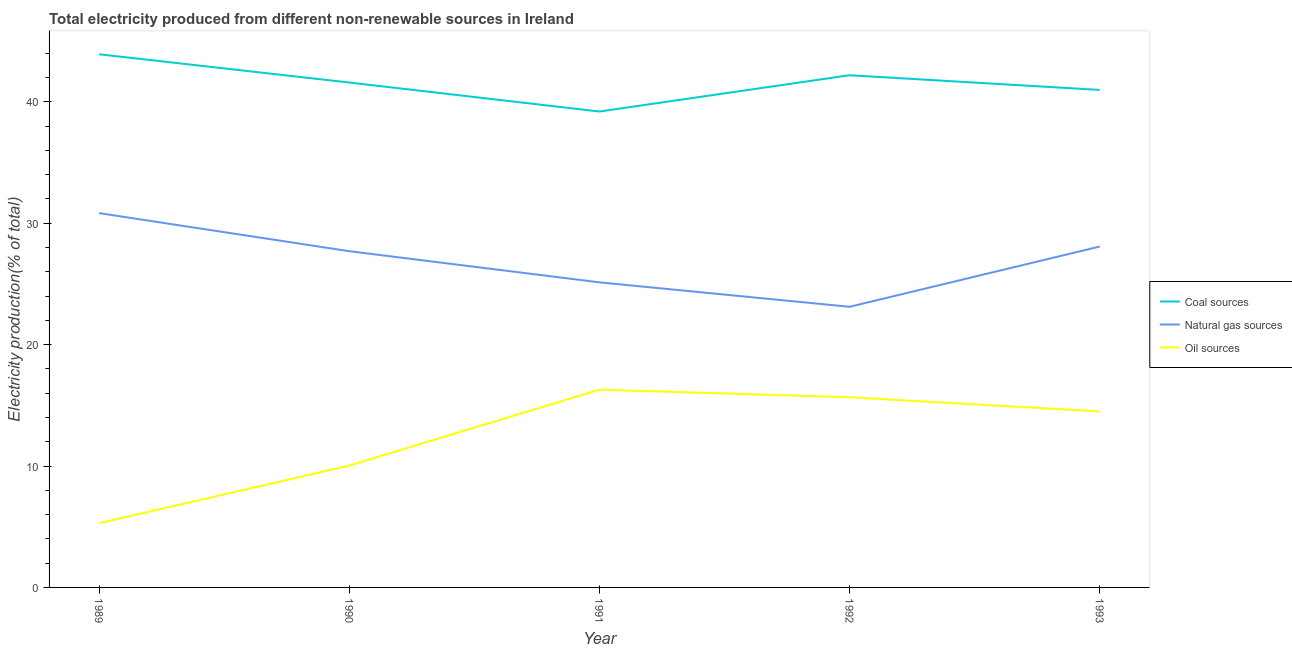How many different coloured lines are there?
Provide a short and direct response. 3. What is the percentage of electricity produced by oil sources in 1990?
Make the answer very short. 10.04. Across all years, what is the maximum percentage of electricity produced by oil sources?
Keep it short and to the point. 16.29. Across all years, what is the minimum percentage of electricity produced by oil sources?
Your answer should be very brief. 5.29. What is the total percentage of electricity produced by oil sources in the graph?
Your response must be concise. 61.78. What is the difference between the percentage of electricity produced by natural gas in 1992 and that in 1993?
Your answer should be very brief. -4.96. What is the difference between the percentage of electricity produced by natural gas in 1990 and the percentage of electricity produced by oil sources in 1993?
Provide a short and direct response. 13.2. What is the average percentage of electricity produced by coal per year?
Provide a short and direct response. 41.58. In the year 1993, what is the difference between the percentage of electricity produced by natural gas and percentage of electricity produced by oil sources?
Offer a terse response. 13.59. What is the ratio of the percentage of electricity produced by oil sources in 1990 to that in 1992?
Provide a succinct answer. 0.64. Is the difference between the percentage of electricity produced by natural gas in 1990 and 1992 greater than the difference between the percentage of electricity produced by oil sources in 1990 and 1992?
Your answer should be compact. Yes. What is the difference between the highest and the second highest percentage of electricity produced by natural gas?
Keep it short and to the point. 2.75. What is the difference between the highest and the lowest percentage of electricity produced by oil sources?
Offer a very short reply. 11. In how many years, is the percentage of electricity produced by natural gas greater than the average percentage of electricity produced by natural gas taken over all years?
Provide a succinct answer. 3. Is the sum of the percentage of electricity produced by natural gas in 1990 and 1991 greater than the maximum percentage of electricity produced by coal across all years?
Your answer should be compact. Yes. Is it the case that in every year, the sum of the percentage of electricity produced by coal and percentage of electricity produced by natural gas is greater than the percentage of electricity produced by oil sources?
Give a very brief answer. Yes. Is the percentage of electricity produced by coal strictly greater than the percentage of electricity produced by natural gas over the years?
Your answer should be compact. Yes. How many years are there in the graph?
Offer a terse response. 5. What is the difference between two consecutive major ticks on the Y-axis?
Your answer should be compact. 10. Does the graph contain any zero values?
Your answer should be compact. No. Where does the legend appear in the graph?
Make the answer very short. Center right. How many legend labels are there?
Provide a short and direct response. 3. What is the title of the graph?
Your answer should be compact. Total electricity produced from different non-renewable sources in Ireland. Does "Natural Gas" appear as one of the legend labels in the graph?
Offer a very short reply. No. What is the label or title of the X-axis?
Keep it short and to the point. Year. What is the label or title of the Y-axis?
Provide a succinct answer. Electricity production(% of total). What is the Electricity production(% of total) of Coal sources in 1989?
Ensure brevity in your answer.  43.92. What is the Electricity production(% of total) in Natural gas sources in 1989?
Offer a terse response. 30.83. What is the Electricity production(% of total) in Oil sources in 1989?
Offer a terse response. 5.29. What is the Electricity production(% of total) in Coal sources in 1990?
Provide a short and direct response. 41.59. What is the Electricity production(% of total) in Natural gas sources in 1990?
Ensure brevity in your answer.  27.7. What is the Electricity production(% of total) in Oil sources in 1990?
Give a very brief answer. 10.04. What is the Electricity production(% of total) in Coal sources in 1991?
Offer a very short reply. 39.2. What is the Electricity production(% of total) of Natural gas sources in 1991?
Your response must be concise. 25.13. What is the Electricity production(% of total) in Oil sources in 1991?
Your answer should be very brief. 16.29. What is the Electricity production(% of total) of Coal sources in 1992?
Your response must be concise. 42.19. What is the Electricity production(% of total) in Natural gas sources in 1992?
Offer a terse response. 23.12. What is the Electricity production(% of total) of Oil sources in 1992?
Keep it short and to the point. 15.67. What is the Electricity production(% of total) of Coal sources in 1993?
Provide a succinct answer. 40.98. What is the Electricity production(% of total) in Natural gas sources in 1993?
Offer a very short reply. 28.08. What is the Electricity production(% of total) of Oil sources in 1993?
Offer a terse response. 14.5. Across all years, what is the maximum Electricity production(% of total) of Coal sources?
Offer a very short reply. 43.92. Across all years, what is the maximum Electricity production(% of total) of Natural gas sources?
Make the answer very short. 30.83. Across all years, what is the maximum Electricity production(% of total) in Oil sources?
Your answer should be compact. 16.29. Across all years, what is the minimum Electricity production(% of total) in Coal sources?
Ensure brevity in your answer.  39.2. Across all years, what is the minimum Electricity production(% of total) of Natural gas sources?
Provide a short and direct response. 23.12. Across all years, what is the minimum Electricity production(% of total) in Oil sources?
Offer a very short reply. 5.29. What is the total Electricity production(% of total) of Coal sources in the graph?
Make the answer very short. 207.89. What is the total Electricity production(% of total) of Natural gas sources in the graph?
Provide a succinct answer. 134.86. What is the total Electricity production(% of total) in Oil sources in the graph?
Make the answer very short. 61.78. What is the difference between the Electricity production(% of total) of Coal sources in 1989 and that in 1990?
Your answer should be compact. 2.33. What is the difference between the Electricity production(% of total) in Natural gas sources in 1989 and that in 1990?
Offer a terse response. 3.14. What is the difference between the Electricity production(% of total) of Oil sources in 1989 and that in 1990?
Provide a succinct answer. -4.75. What is the difference between the Electricity production(% of total) in Coal sources in 1989 and that in 1991?
Your answer should be compact. 4.72. What is the difference between the Electricity production(% of total) in Natural gas sources in 1989 and that in 1991?
Your answer should be very brief. 5.7. What is the difference between the Electricity production(% of total) in Oil sources in 1989 and that in 1991?
Ensure brevity in your answer.  -11. What is the difference between the Electricity production(% of total) of Coal sources in 1989 and that in 1992?
Your response must be concise. 1.73. What is the difference between the Electricity production(% of total) in Natural gas sources in 1989 and that in 1992?
Provide a succinct answer. 7.72. What is the difference between the Electricity production(% of total) in Oil sources in 1989 and that in 1992?
Ensure brevity in your answer.  -10.38. What is the difference between the Electricity production(% of total) in Coal sources in 1989 and that in 1993?
Ensure brevity in your answer.  2.94. What is the difference between the Electricity production(% of total) in Natural gas sources in 1989 and that in 1993?
Your response must be concise. 2.75. What is the difference between the Electricity production(% of total) of Oil sources in 1989 and that in 1993?
Offer a terse response. -9.21. What is the difference between the Electricity production(% of total) in Coal sources in 1990 and that in 1991?
Your response must be concise. 2.39. What is the difference between the Electricity production(% of total) in Natural gas sources in 1990 and that in 1991?
Your answer should be compact. 2.57. What is the difference between the Electricity production(% of total) of Oil sources in 1990 and that in 1991?
Provide a succinct answer. -6.25. What is the difference between the Electricity production(% of total) in Coal sources in 1990 and that in 1992?
Your answer should be very brief. -0.6. What is the difference between the Electricity production(% of total) in Natural gas sources in 1990 and that in 1992?
Provide a succinct answer. 4.58. What is the difference between the Electricity production(% of total) in Oil sources in 1990 and that in 1992?
Keep it short and to the point. -5.63. What is the difference between the Electricity production(% of total) of Coal sources in 1990 and that in 1993?
Your answer should be compact. 0.61. What is the difference between the Electricity production(% of total) in Natural gas sources in 1990 and that in 1993?
Provide a short and direct response. -0.39. What is the difference between the Electricity production(% of total) of Oil sources in 1990 and that in 1993?
Provide a short and direct response. -4.46. What is the difference between the Electricity production(% of total) in Coal sources in 1991 and that in 1992?
Provide a short and direct response. -2.99. What is the difference between the Electricity production(% of total) in Natural gas sources in 1991 and that in 1992?
Provide a short and direct response. 2.01. What is the difference between the Electricity production(% of total) of Oil sources in 1991 and that in 1992?
Make the answer very short. 0.62. What is the difference between the Electricity production(% of total) of Coal sources in 1991 and that in 1993?
Offer a terse response. -1.78. What is the difference between the Electricity production(% of total) of Natural gas sources in 1991 and that in 1993?
Offer a very short reply. -2.95. What is the difference between the Electricity production(% of total) in Oil sources in 1991 and that in 1993?
Give a very brief answer. 1.79. What is the difference between the Electricity production(% of total) in Coal sources in 1992 and that in 1993?
Provide a short and direct response. 1.21. What is the difference between the Electricity production(% of total) in Natural gas sources in 1992 and that in 1993?
Make the answer very short. -4.96. What is the difference between the Electricity production(% of total) of Oil sources in 1992 and that in 1993?
Keep it short and to the point. 1.17. What is the difference between the Electricity production(% of total) of Coal sources in 1989 and the Electricity production(% of total) of Natural gas sources in 1990?
Provide a short and direct response. 16.22. What is the difference between the Electricity production(% of total) in Coal sources in 1989 and the Electricity production(% of total) in Oil sources in 1990?
Your answer should be compact. 33.88. What is the difference between the Electricity production(% of total) in Natural gas sources in 1989 and the Electricity production(% of total) in Oil sources in 1990?
Your answer should be compact. 20.8. What is the difference between the Electricity production(% of total) of Coal sources in 1989 and the Electricity production(% of total) of Natural gas sources in 1991?
Keep it short and to the point. 18.79. What is the difference between the Electricity production(% of total) of Coal sources in 1989 and the Electricity production(% of total) of Oil sources in 1991?
Make the answer very short. 27.63. What is the difference between the Electricity production(% of total) of Natural gas sources in 1989 and the Electricity production(% of total) of Oil sources in 1991?
Your answer should be compact. 14.54. What is the difference between the Electricity production(% of total) of Coal sources in 1989 and the Electricity production(% of total) of Natural gas sources in 1992?
Your response must be concise. 20.8. What is the difference between the Electricity production(% of total) in Coal sources in 1989 and the Electricity production(% of total) in Oil sources in 1992?
Offer a very short reply. 28.25. What is the difference between the Electricity production(% of total) in Natural gas sources in 1989 and the Electricity production(% of total) in Oil sources in 1992?
Your answer should be compact. 15.17. What is the difference between the Electricity production(% of total) in Coal sources in 1989 and the Electricity production(% of total) in Natural gas sources in 1993?
Offer a terse response. 15.84. What is the difference between the Electricity production(% of total) of Coal sources in 1989 and the Electricity production(% of total) of Oil sources in 1993?
Make the answer very short. 29.42. What is the difference between the Electricity production(% of total) of Natural gas sources in 1989 and the Electricity production(% of total) of Oil sources in 1993?
Your response must be concise. 16.34. What is the difference between the Electricity production(% of total) of Coal sources in 1990 and the Electricity production(% of total) of Natural gas sources in 1991?
Give a very brief answer. 16.46. What is the difference between the Electricity production(% of total) of Coal sources in 1990 and the Electricity production(% of total) of Oil sources in 1991?
Offer a terse response. 25.3. What is the difference between the Electricity production(% of total) in Natural gas sources in 1990 and the Electricity production(% of total) in Oil sources in 1991?
Give a very brief answer. 11.41. What is the difference between the Electricity production(% of total) of Coal sources in 1990 and the Electricity production(% of total) of Natural gas sources in 1992?
Give a very brief answer. 18.47. What is the difference between the Electricity production(% of total) in Coal sources in 1990 and the Electricity production(% of total) in Oil sources in 1992?
Offer a very short reply. 25.93. What is the difference between the Electricity production(% of total) of Natural gas sources in 1990 and the Electricity production(% of total) of Oil sources in 1992?
Your answer should be very brief. 12.03. What is the difference between the Electricity production(% of total) in Coal sources in 1990 and the Electricity production(% of total) in Natural gas sources in 1993?
Keep it short and to the point. 13.51. What is the difference between the Electricity production(% of total) of Coal sources in 1990 and the Electricity production(% of total) of Oil sources in 1993?
Offer a very short reply. 27.09. What is the difference between the Electricity production(% of total) in Natural gas sources in 1990 and the Electricity production(% of total) in Oil sources in 1993?
Provide a short and direct response. 13.2. What is the difference between the Electricity production(% of total) in Coal sources in 1991 and the Electricity production(% of total) in Natural gas sources in 1992?
Keep it short and to the point. 16.09. What is the difference between the Electricity production(% of total) in Coal sources in 1991 and the Electricity production(% of total) in Oil sources in 1992?
Ensure brevity in your answer.  23.54. What is the difference between the Electricity production(% of total) of Natural gas sources in 1991 and the Electricity production(% of total) of Oil sources in 1992?
Keep it short and to the point. 9.47. What is the difference between the Electricity production(% of total) of Coal sources in 1991 and the Electricity production(% of total) of Natural gas sources in 1993?
Your answer should be compact. 11.12. What is the difference between the Electricity production(% of total) in Coal sources in 1991 and the Electricity production(% of total) in Oil sources in 1993?
Offer a terse response. 24.71. What is the difference between the Electricity production(% of total) in Natural gas sources in 1991 and the Electricity production(% of total) in Oil sources in 1993?
Make the answer very short. 10.63. What is the difference between the Electricity production(% of total) of Coal sources in 1992 and the Electricity production(% of total) of Natural gas sources in 1993?
Make the answer very short. 14.11. What is the difference between the Electricity production(% of total) in Coal sources in 1992 and the Electricity production(% of total) in Oil sources in 1993?
Your response must be concise. 27.7. What is the difference between the Electricity production(% of total) of Natural gas sources in 1992 and the Electricity production(% of total) of Oil sources in 1993?
Ensure brevity in your answer.  8.62. What is the average Electricity production(% of total) in Coal sources per year?
Give a very brief answer. 41.58. What is the average Electricity production(% of total) of Natural gas sources per year?
Your answer should be very brief. 26.97. What is the average Electricity production(% of total) of Oil sources per year?
Make the answer very short. 12.36. In the year 1989, what is the difference between the Electricity production(% of total) of Coal sources and Electricity production(% of total) of Natural gas sources?
Your answer should be very brief. 13.09. In the year 1989, what is the difference between the Electricity production(% of total) of Coal sources and Electricity production(% of total) of Oil sources?
Offer a very short reply. 38.63. In the year 1989, what is the difference between the Electricity production(% of total) of Natural gas sources and Electricity production(% of total) of Oil sources?
Offer a very short reply. 25.54. In the year 1990, what is the difference between the Electricity production(% of total) of Coal sources and Electricity production(% of total) of Natural gas sources?
Ensure brevity in your answer.  13.89. In the year 1990, what is the difference between the Electricity production(% of total) in Coal sources and Electricity production(% of total) in Oil sources?
Provide a short and direct response. 31.56. In the year 1990, what is the difference between the Electricity production(% of total) in Natural gas sources and Electricity production(% of total) in Oil sources?
Give a very brief answer. 17.66. In the year 1991, what is the difference between the Electricity production(% of total) in Coal sources and Electricity production(% of total) in Natural gas sources?
Keep it short and to the point. 14.07. In the year 1991, what is the difference between the Electricity production(% of total) of Coal sources and Electricity production(% of total) of Oil sources?
Ensure brevity in your answer.  22.91. In the year 1991, what is the difference between the Electricity production(% of total) in Natural gas sources and Electricity production(% of total) in Oil sources?
Provide a short and direct response. 8.84. In the year 1992, what is the difference between the Electricity production(% of total) of Coal sources and Electricity production(% of total) of Natural gas sources?
Make the answer very short. 19.07. In the year 1992, what is the difference between the Electricity production(% of total) of Coal sources and Electricity production(% of total) of Oil sources?
Make the answer very short. 26.53. In the year 1992, what is the difference between the Electricity production(% of total) of Natural gas sources and Electricity production(% of total) of Oil sources?
Provide a succinct answer. 7.45. In the year 1993, what is the difference between the Electricity production(% of total) of Coal sources and Electricity production(% of total) of Natural gas sources?
Your answer should be very brief. 12.9. In the year 1993, what is the difference between the Electricity production(% of total) in Coal sources and Electricity production(% of total) in Oil sources?
Your answer should be very brief. 26.48. In the year 1993, what is the difference between the Electricity production(% of total) in Natural gas sources and Electricity production(% of total) in Oil sources?
Your answer should be very brief. 13.59. What is the ratio of the Electricity production(% of total) of Coal sources in 1989 to that in 1990?
Your answer should be compact. 1.06. What is the ratio of the Electricity production(% of total) in Natural gas sources in 1989 to that in 1990?
Provide a short and direct response. 1.11. What is the ratio of the Electricity production(% of total) of Oil sources in 1989 to that in 1990?
Your answer should be very brief. 0.53. What is the ratio of the Electricity production(% of total) in Coal sources in 1989 to that in 1991?
Offer a very short reply. 1.12. What is the ratio of the Electricity production(% of total) in Natural gas sources in 1989 to that in 1991?
Offer a terse response. 1.23. What is the ratio of the Electricity production(% of total) of Oil sources in 1989 to that in 1991?
Your answer should be very brief. 0.32. What is the ratio of the Electricity production(% of total) of Coal sources in 1989 to that in 1992?
Your answer should be very brief. 1.04. What is the ratio of the Electricity production(% of total) of Natural gas sources in 1989 to that in 1992?
Give a very brief answer. 1.33. What is the ratio of the Electricity production(% of total) in Oil sources in 1989 to that in 1992?
Ensure brevity in your answer.  0.34. What is the ratio of the Electricity production(% of total) in Coal sources in 1989 to that in 1993?
Give a very brief answer. 1.07. What is the ratio of the Electricity production(% of total) of Natural gas sources in 1989 to that in 1993?
Give a very brief answer. 1.1. What is the ratio of the Electricity production(% of total) in Oil sources in 1989 to that in 1993?
Your answer should be compact. 0.36. What is the ratio of the Electricity production(% of total) of Coal sources in 1990 to that in 1991?
Make the answer very short. 1.06. What is the ratio of the Electricity production(% of total) of Natural gas sources in 1990 to that in 1991?
Your answer should be compact. 1.1. What is the ratio of the Electricity production(% of total) of Oil sources in 1990 to that in 1991?
Your answer should be very brief. 0.62. What is the ratio of the Electricity production(% of total) in Coal sources in 1990 to that in 1992?
Offer a terse response. 0.99. What is the ratio of the Electricity production(% of total) in Natural gas sources in 1990 to that in 1992?
Provide a succinct answer. 1.2. What is the ratio of the Electricity production(% of total) of Oil sources in 1990 to that in 1992?
Offer a terse response. 0.64. What is the ratio of the Electricity production(% of total) in Coal sources in 1990 to that in 1993?
Give a very brief answer. 1.01. What is the ratio of the Electricity production(% of total) in Natural gas sources in 1990 to that in 1993?
Your answer should be very brief. 0.99. What is the ratio of the Electricity production(% of total) in Oil sources in 1990 to that in 1993?
Offer a terse response. 0.69. What is the ratio of the Electricity production(% of total) in Coal sources in 1991 to that in 1992?
Provide a short and direct response. 0.93. What is the ratio of the Electricity production(% of total) of Natural gas sources in 1991 to that in 1992?
Offer a terse response. 1.09. What is the ratio of the Electricity production(% of total) of Oil sources in 1991 to that in 1992?
Keep it short and to the point. 1.04. What is the ratio of the Electricity production(% of total) of Coal sources in 1991 to that in 1993?
Provide a succinct answer. 0.96. What is the ratio of the Electricity production(% of total) in Natural gas sources in 1991 to that in 1993?
Provide a short and direct response. 0.89. What is the ratio of the Electricity production(% of total) of Oil sources in 1991 to that in 1993?
Your answer should be compact. 1.12. What is the ratio of the Electricity production(% of total) in Coal sources in 1992 to that in 1993?
Offer a terse response. 1.03. What is the ratio of the Electricity production(% of total) in Natural gas sources in 1992 to that in 1993?
Provide a short and direct response. 0.82. What is the ratio of the Electricity production(% of total) of Oil sources in 1992 to that in 1993?
Provide a succinct answer. 1.08. What is the difference between the highest and the second highest Electricity production(% of total) of Coal sources?
Your response must be concise. 1.73. What is the difference between the highest and the second highest Electricity production(% of total) in Natural gas sources?
Ensure brevity in your answer.  2.75. What is the difference between the highest and the second highest Electricity production(% of total) of Oil sources?
Your response must be concise. 0.62. What is the difference between the highest and the lowest Electricity production(% of total) in Coal sources?
Keep it short and to the point. 4.72. What is the difference between the highest and the lowest Electricity production(% of total) of Natural gas sources?
Your answer should be very brief. 7.72. What is the difference between the highest and the lowest Electricity production(% of total) in Oil sources?
Offer a terse response. 11. 